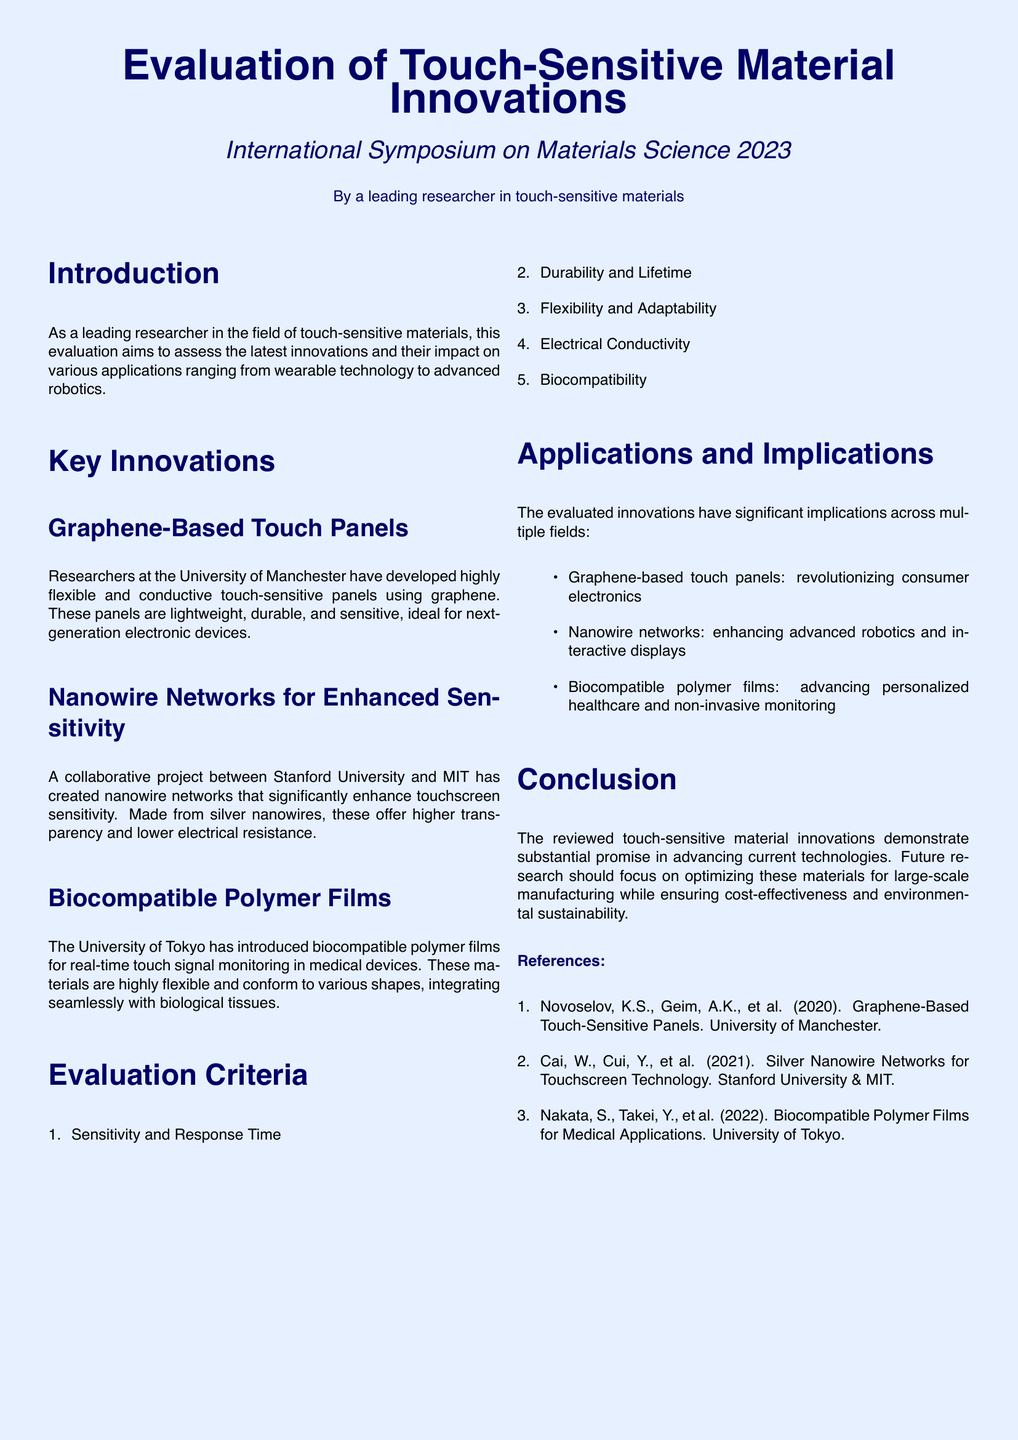What is the title of the document? The title is specified at the top of the document, indicating the main focus of the evaluation.
Answer: Evaluation of Touch-Sensitive Material Innovations Who developed the graphene-based touch panels? The document mentions the researchers' affiliation, which specifies who is behind the innovation.
Answer: University of Manchester What is one of the evaluation criteria? The criteria listed in the document cover various aspects of the materials being evaluated.
Answer: Sensitivity and Response Time Which institution introduced biocompatible polymer films? The document identifies the institution associated with a specific innovation related to medical applications.
Answer: University of Tokyo What material is used in the nanowire networks? The document provides specific information about the composition of the nanowire networks.
Answer: Silver nanowires What is a major application of graphene-based touch panels? The document discusses implications of the innovations in various fields, highlighting important applications.
Answer: Revolutionizing consumer electronics Why should future research focus on optimizing these materials? The document concludes by emphasizing the need for certain aspects to be considered in future work.
Answer: Large-scale manufacturing What type of materials are nano-wires networks enhancing? The document connects the specific innovation to its uses in a particular sector or application.
Answer: Touchscreen technology How are biocompatible polymer films described in the document? The document contains descriptions of the materials, focusing on their characteristics.
Answer: Highly flexible and conform to various shapes 